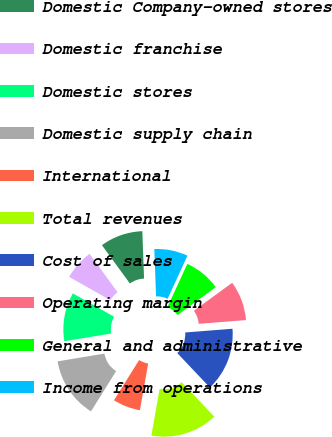<chart> <loc_0><loc_0><loc_500><loc_500><pie_chart><fcel>Domestic Company-owned stores<fcel>Domestic franchise<fcel>Domestic stores<fcel>Domestic supply chain<fcel>International<fcel>Total revenues<fcel>Cost of sales<fcel>Operating margin<fcel>General and administrative<fcel>Income from operations<nl><fcel>9.46%<fcel>6.76%<fcel>10.81%<fcel>13.51%<fcel>6.08%<fcel>14.86%<fcel>14.19%<fcel>8.78%<fcel>8.11%<fcel>7.43%<nl></chart> 